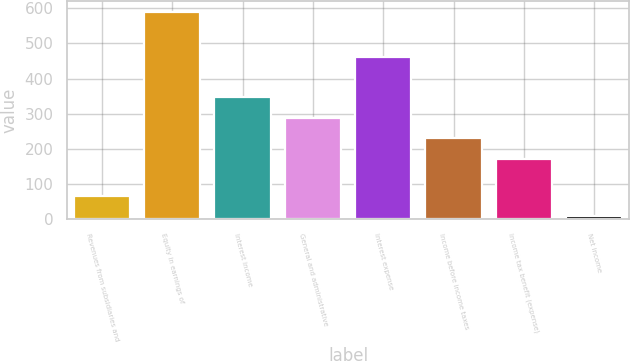<chart> <loc_0><loc_0><loc_500><loc_500><bar_chart><fcel>Revenues from subsidiaries and<fcel>Equity in earnings of<fcel>Interest income<fcel>General and administrative<fcel>Interest expense<fcel>Income before income taxes<fcel>Income tax benefit (expense)<fcel>Net income<nl><fcel>67.1<fcel>590<fcel>346.3<fcel>288.2<fcel>461<fcel>230.1<fcel>172<fcel>9<nl></chart> 